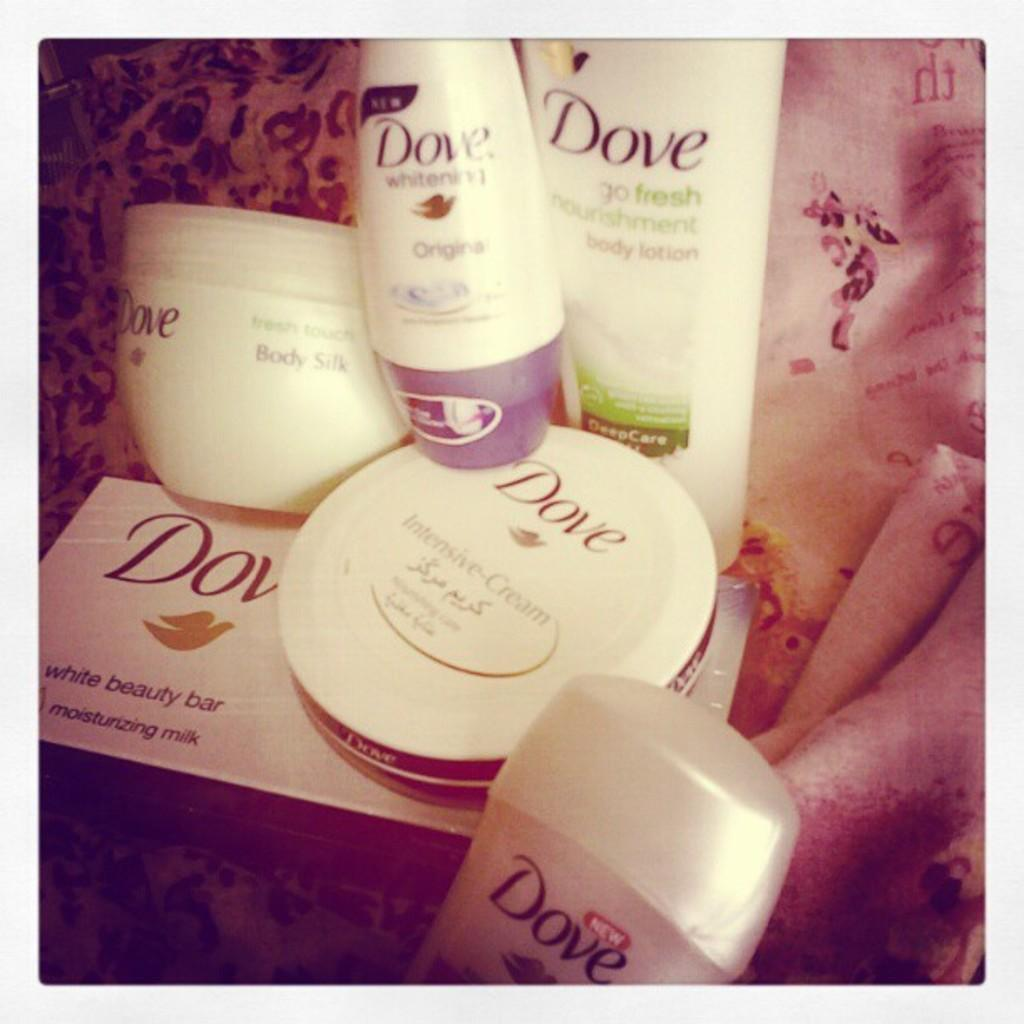<image>
Share a concise interpretation of the image provided. several Dove beauty products like beauty bar and Cream 